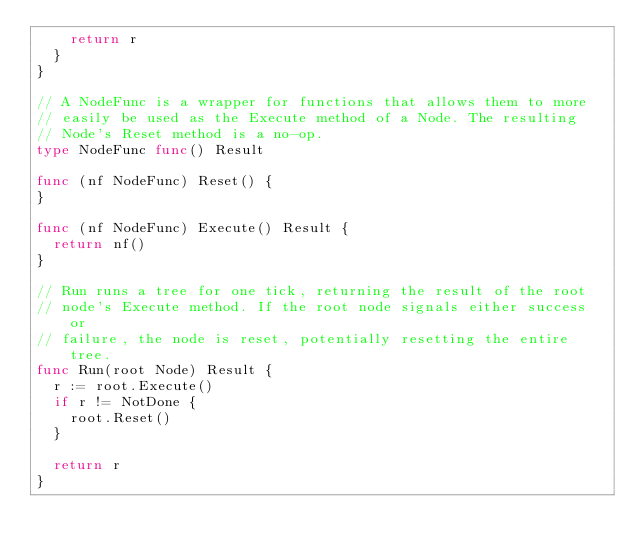Convert code to text. <code><loc_0><loc_0><loc_500><loc_500><_Go_>		return r
	}
}

// A NodeFunc is a wrapper for functions that allows them to more
// easily be used as the Execute method of a Node. The resulting
// Node's Reset method is a no-op.
type NodeFunc func() Result

func (nf NodeFunc) Reset() {
}

func (nf NodeFunc) Execute() Result {
	return nf()
}

// Run runs a tree for one tick, returning the result of the root
// node's Execute method. If the root node signals either success or
// failure, the node is reset, potentially resetting the entire tree.
func Run(root Node) Result {
	r := root.Execute()
	if r != NotDone {
		root.Reset()
	}

	return r
}
</code> 